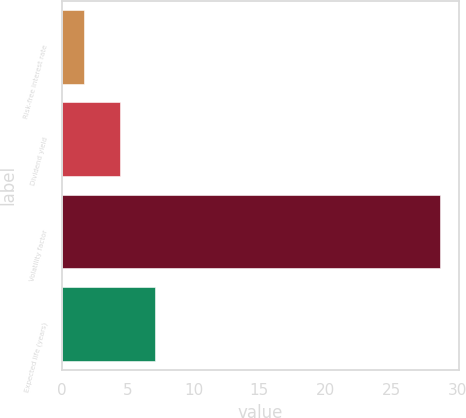<chart> <loc_0><loc_0><loc_500><loc_500><bar_chart><fcel>Risk-free interest rate<fcel>Dividend yield<fcel>Volatility factor<fcel>Expected life (years)<nl><fcel>1.71<fcel>4.41<fcel>28.68<fcel>7.11<nl></chart> 